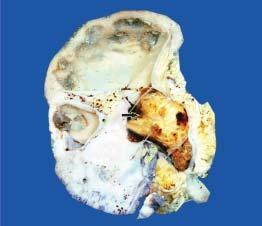does the bronchial wall contain a single, large, soft yellow white stone taking the contour of the pelvi-calyceal system arrow?
Answer the question using a single word or phrase. No 